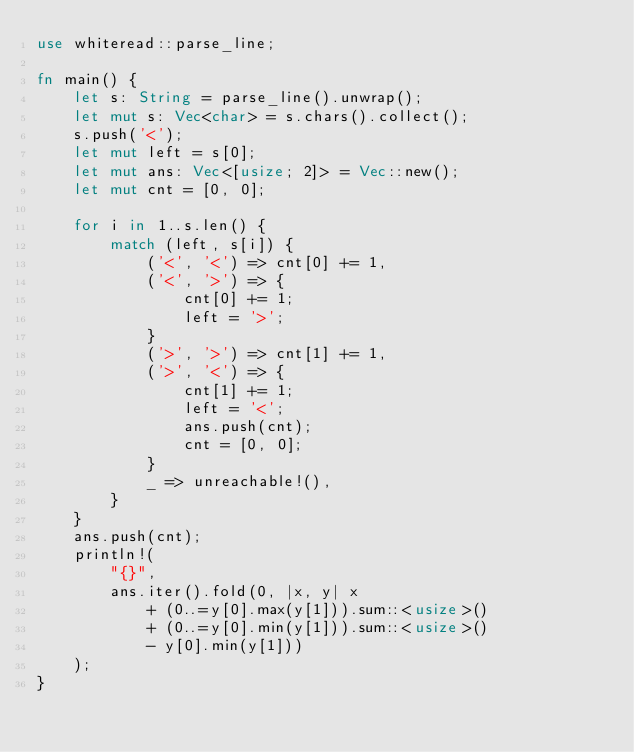<code> <loc_0><loc_0><loc_500><loc_500><_Rust_>use whiteread::parse_line;

fn main() {
    let s: String = parse_line().unwrap();
    let mut s: Vec<char> = s.chars().collect();
    s.push('<');
    let mut left = s[0];
    let mut ans: Vec<[usize; 2]> = Vec::new();
    let mut cnt = [0, 0];

    for i in 1..s.len() {
        match (left, s[i]) {
            ('<', '<') => cnt[0] += 1,
            ('<', '>') => {
                cnt[0] += 1;
                left = '>';
            }
            ('>', '>') => cnt[1] += 1,
            ('>', '<') => {
                cnt[1] += 1;
                left = '<';
                ans.push(cnt);
                cnt = [0, 0];
            }
            _ => unreachable!(),
        }
    }
    ans.push(cnt);
    println!(
        "{}",
        ans.iter().fold(0, |x, y| x
            + (0..=y[0].max(y[1])).sum::<usize>()
            + (0..=y[0].min(y[1])).sum::<usize>()
            - y[0].min(y[1]))
    );
}
</code> 